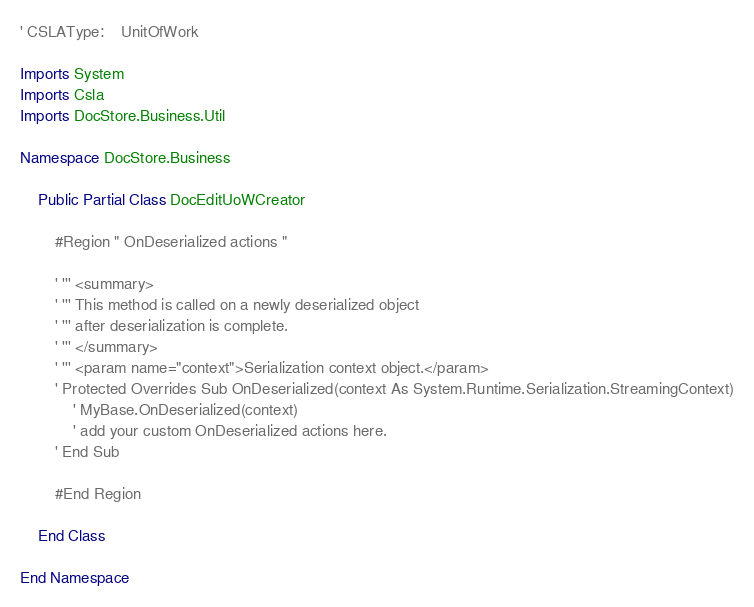Convert code to text. <code><loc_0><loc_0><loc_500><loc_500><_VisualBasic_>' CSLAType:    UnitOfWork

Imports System
Imports Csla
Imports DocStore.Business.Util

Namespace DocStore.Business

    Public Partial Class DocEditUoWCreator

        #Region " OnDeserialized actions "

        ' ''' <summary>
        ' ''' This method is called on a newly deserialized object
        ' ''' after deserialization is complete.
        ' ''' </summary>
        ' ''' <param name="context">Serialization context object.</param>
        ' Protected Overrides Sub OnDeserialized(context As System.Runtime.Serialization.StreamingContext)
            ' MyBase.OnDeserialized(context)
            ' add your custom OnDeserialized actions here.
        ' End Sub

        #End Region

    End Class

End Namespace
</code> 